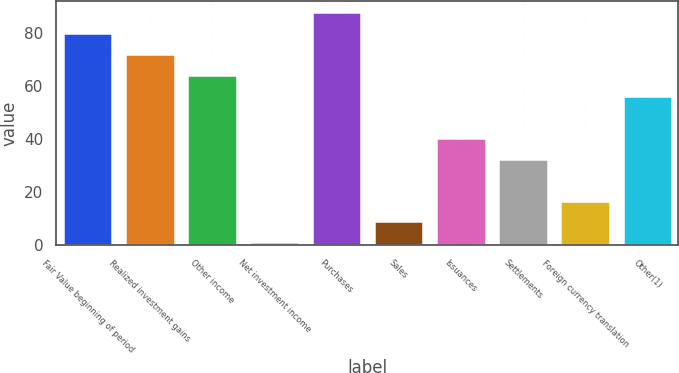Convert chart. <chart><loc_0><loc_0><loc_500><loc_500><bar_chart><fcel>Fair Value beginning of period<fcel>Realized investment gains<fcel>Other income<fcel>Net investment income<fcel>Purchases<fcel>Sales<fcel>Issuances<fcel>Settlements<fcel>Foreign currency translation<fcel>Other(1)<nl><fcel>80<fcel>72.1<fcel>64.2<fcel>1<fcel>87.9<fcel>8.9<fcel>40.5<fcel>32.6<fcel>16.8<fcel>56.3<nl></chart> 